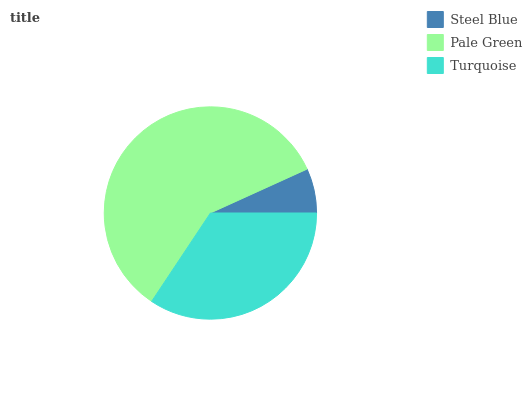Is Steel Blue the minimum?
Answer yes or no. Yes. Is Pale Green the maximum?
Answer yes or no. Yes. Is Turquoise the minimum?
Answer yes or no. No. Is Turquoise the maximum?
Answer yes or no. No. Is Pale Green greater than Turquoise?
Answer yes or no. Yes. Is Turquoise less than Pale Green?
Answer yes or no. Yes. Is Turquoise greater than Pale Green?
Answer yes or no. No. Is Pale Green less than Turquoise?
Answer yes or no. No. Is Turquoise the high median?
Answer yes or no. Yes. Is Turquoise the low median?
Answer yes or no. Yes. Is Pale Green the high median?
Answer yes or no. No. Is Pale Green the low median?
Answer yes or no. No. 